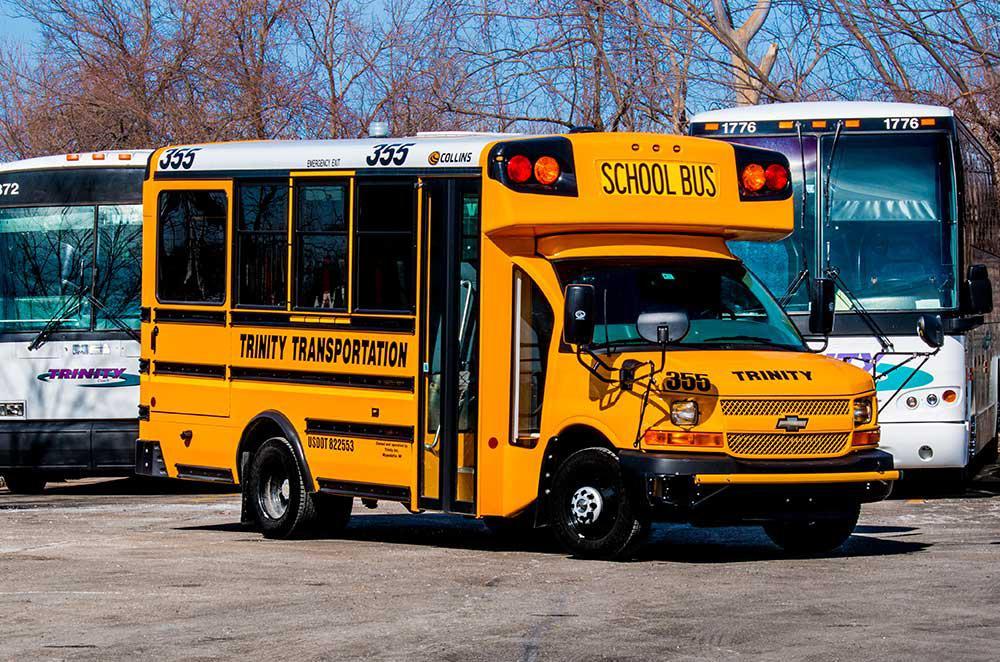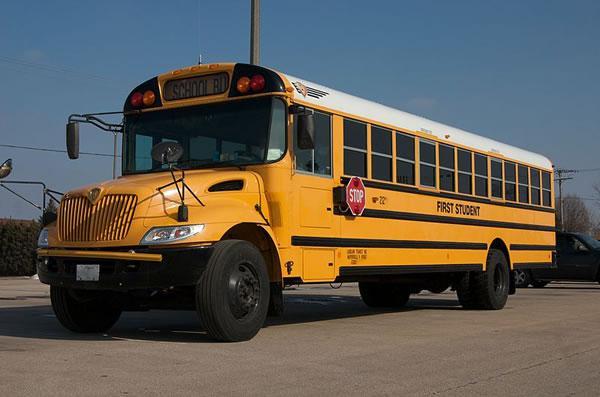The first image is the image on the left, the second image is the image on the right. For the images shown, is this caption "In at least one image there is an emergency exit in the back of the bus face forward with the front of the bus not visible." true? Answer yes or no. No. The first image is the image on the left, the second image is the image on the right. Assess this claim about the two images: "The right image shows a flat-fronted bus angled facing forward.". Correct or not? Answer yes or no. No. 